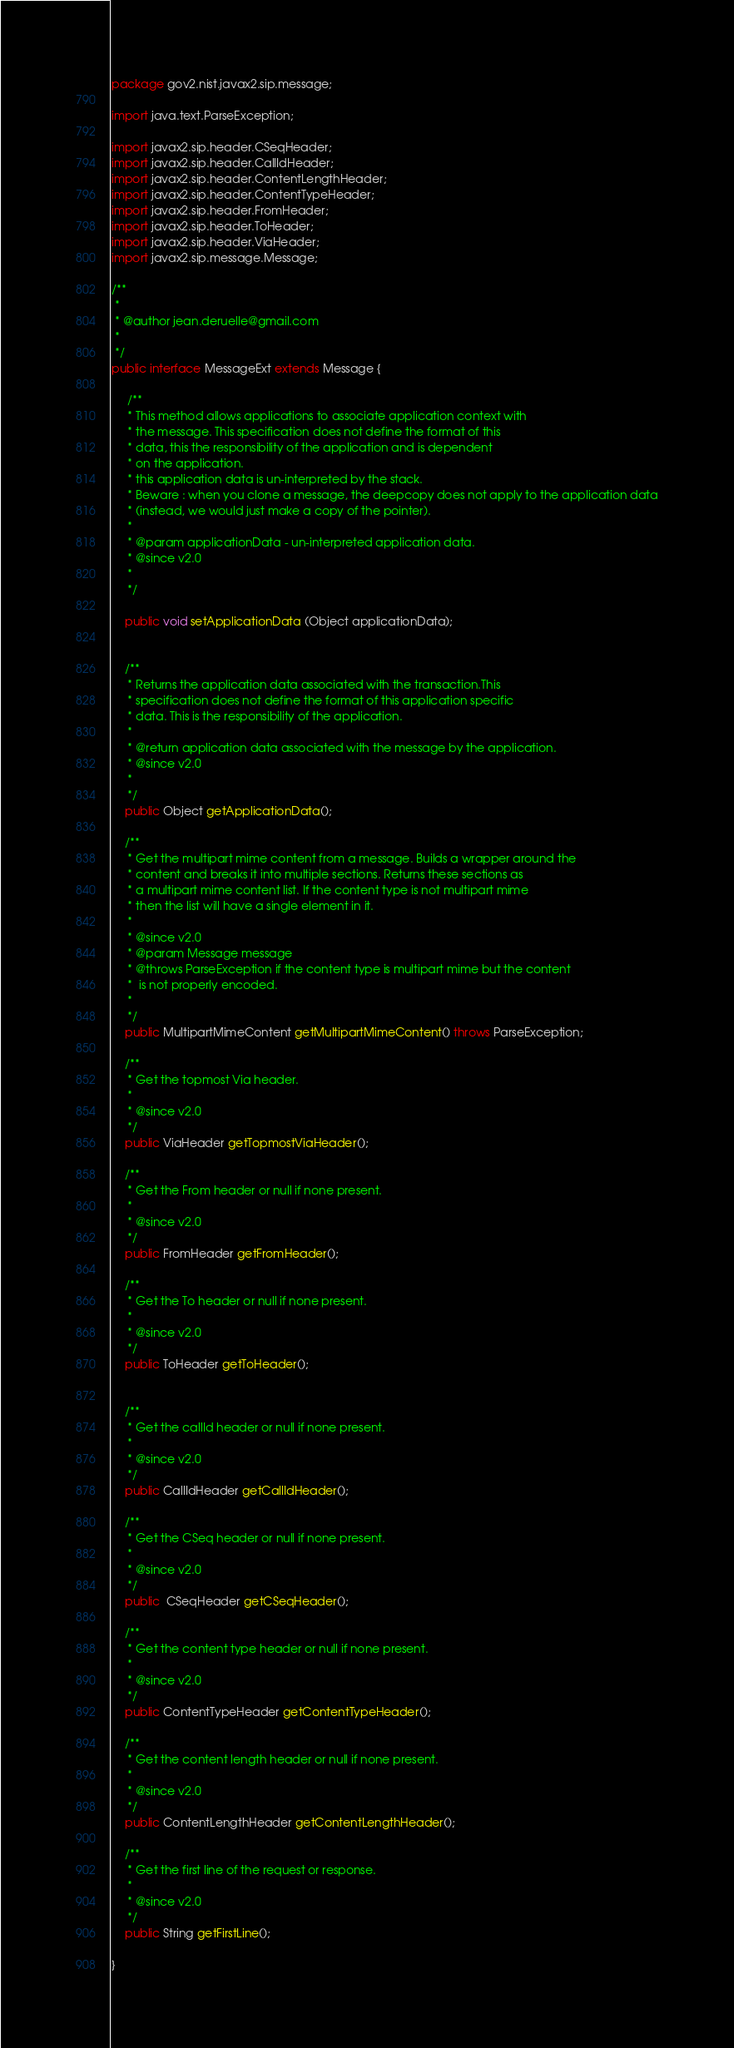<code> <loc_0><loc_0><loc_500><loc_500><_Java_>package gov2.nist.javax2.sip.message;

import java.text.ParseException;

import javax2.sip.header.CSeqHeader;
import javax2.sip.header.CallIdHeader;
import javax2.sip.header.ContentLengthHeader;
import javax2.sip.header.ContentTypeHeader;
import javax2.sip.header.FromHeader;
import javax2.sip.header.ToHeader;
import javax2.sip.header.ViaHeader;
import javax2.sip.message.Message;

/**
 *
 * @author jean.deruelle@gmail.com
 *
 */
public interface MessageExt extends Message {

     /**
     * This method allows applications to associate application context with
     * the message. This specification does not define the format of this
     * data, this the responsibility of the application and is dependent
     * on the application.
     * this application data is un-interpreted by the stack.
     * Beware : when you clone a message, the deepcopy does not apply to the application data
     * (instead, we would just make a copy of the pointer).
     *
     * @param applicationData - un-interpreted application data.
     * @since v2.0
     *
     */

    public void setApplicationData (Object applicationData);


    /**
     * Returns the application data associated with the transaction.This
     * specification does not define the format of this application specific
     * data. This is the responsibility of the application.
     *
     * @return application data associated with the message by the application.
     * @since v2.0
     *
     */
    public Object getApplicationData();
    
    /**
     * Get the multipart mime content from a message. Builds a wrapper around the
     * content and breaks it into multiple sections. Returns these sections as
     * a multipart mime content list. If the content type is not multipart mime
     * then the list will have a single element in it. 
     * 
     * @since v2.0
     * @param Message message
     * @throws ParseException if the content type is multipart mime but the content
     *  is not properly encoded.
     *  
     */
    public MultipartMimeContent getMultipartMimeContent() throws ParseException;
    
    /**
     * Get the topmost Via header.
     * 
     * @since v2.0
     */
    public ViaHeader getTopmostViaHeader();
    
    /**
     * Get the From header or null if none present.
     * 
     * @since v2.0
     */
    public FromHeader getFromHeader();
    
    /**
     * Get the To header or null if none present.
     * 
     * @since v2.0
     */
    public ToHeader getToHeader();
    
    
    /**
     * Get the callId header or null if none present.
     * 
     * @since v2.0
     */
    public CallIdHeader getCallIdHeader();
    
    /**
     * Get the CSeq header or null if none present.
     * 
     * @since v2.0
     */
    public  CSeqHeader getCSeqHeader();
    
    /**
     * Get the content type header or null if none present.
     * 
     * @since v2.0
     */
    public ContentTypeHeader getContentTypeHeader();
    
    /**
     * Get the content length header or null if none present.
     * 
     * @since v2.0
     */
    public ContentLengthHeader getContentLengthHeader();
    
    /**
     * Get the first line of the request or response.
     * 
     * @since v2.0
     */
    public String getFirstLine();

}
</code> 